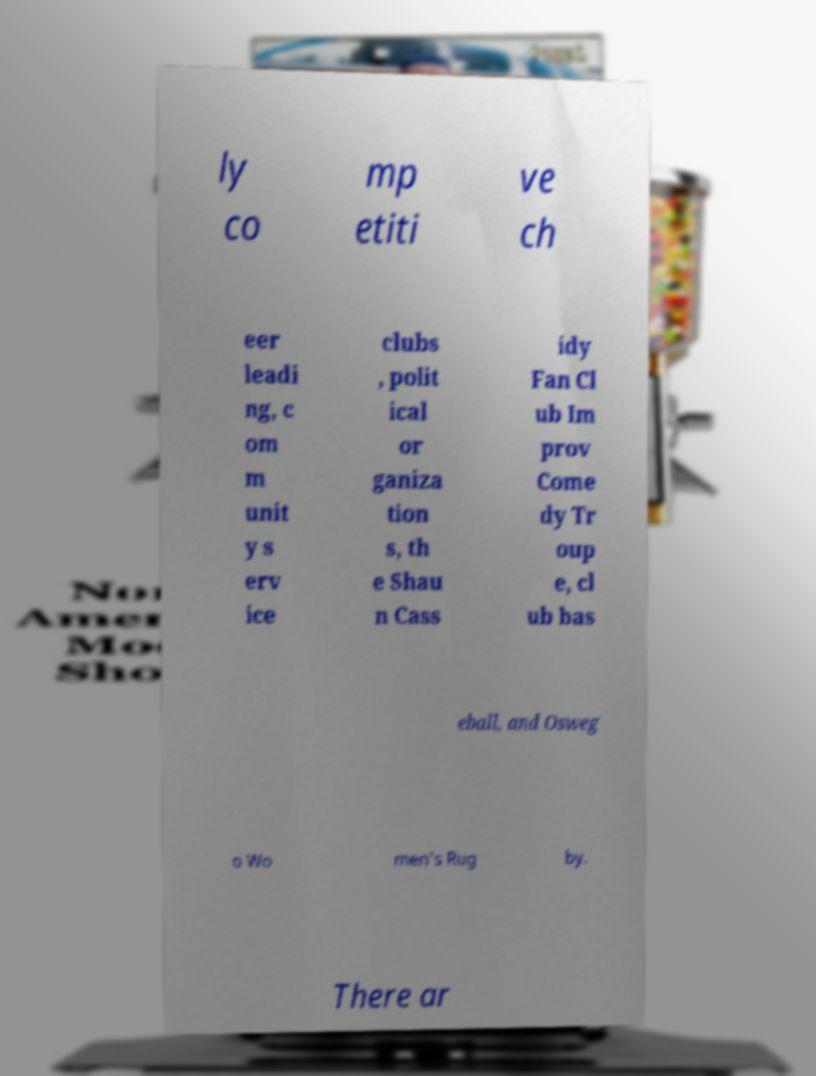Can you read and provide the text displayed in the image?This photo seems to have some interesting text. Can you extract and type it out for me? ly co mp etiti ve ch eer leadi ng, c om m unit y s erv ice clubs , polit ical or ganiza tion s, th e Shau n Cass idy Fan Cl ub Im prov Come dy Tr oup e, cl ub bas eball, and Osweg o Wo men's Rug by. There ar 